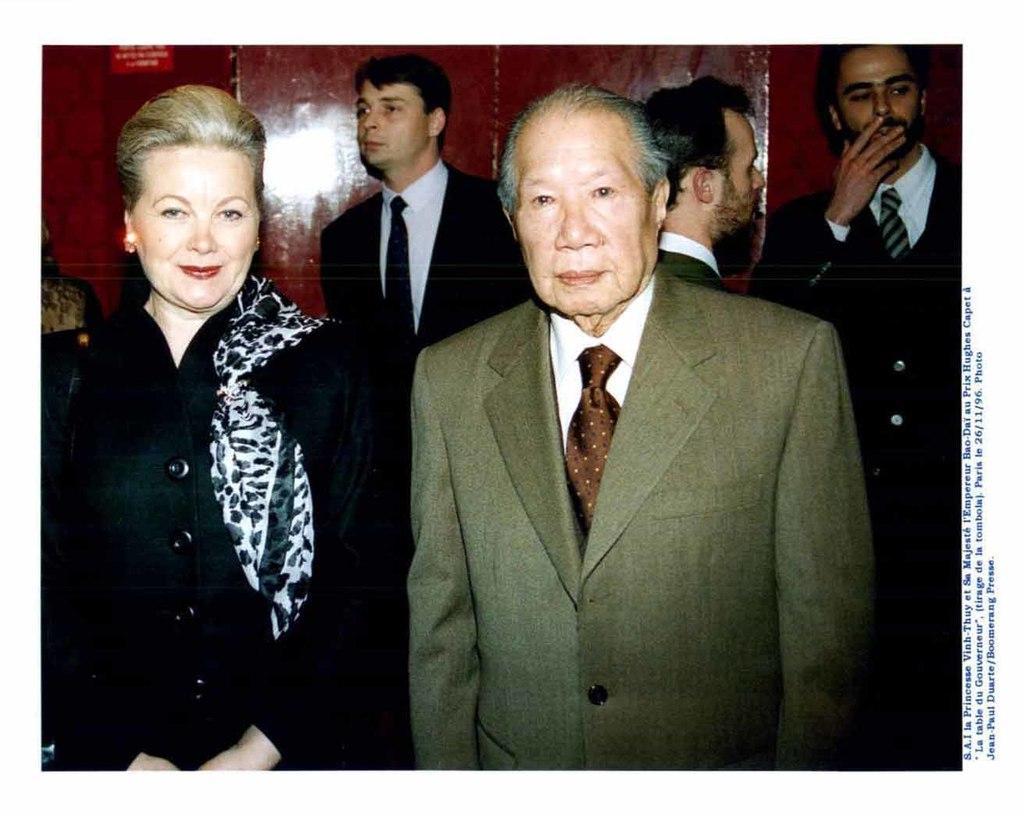How would you summarize this image in a sentence or two? This image is taken indoors. In the background there is a wall and a board with a text on it. In the middle of the image a man and a woman are standing on the floor and there are three men behind a man. 